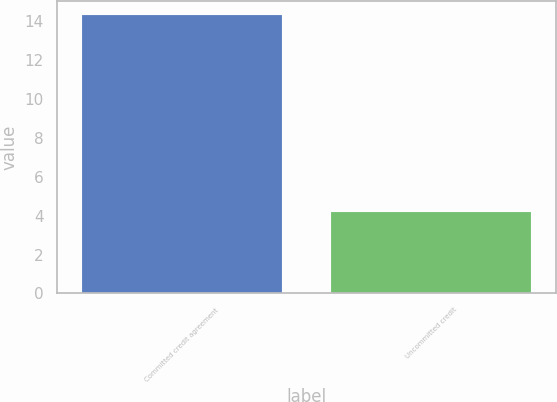Convert chart. <chart><loc_0><loc_0><loc_500><loc_500><bar_chart><fcel>Committed credit agreement<fcel>Uncommitted credit<nl><fcel>14.3<fcel>4.2<nl></chart> 